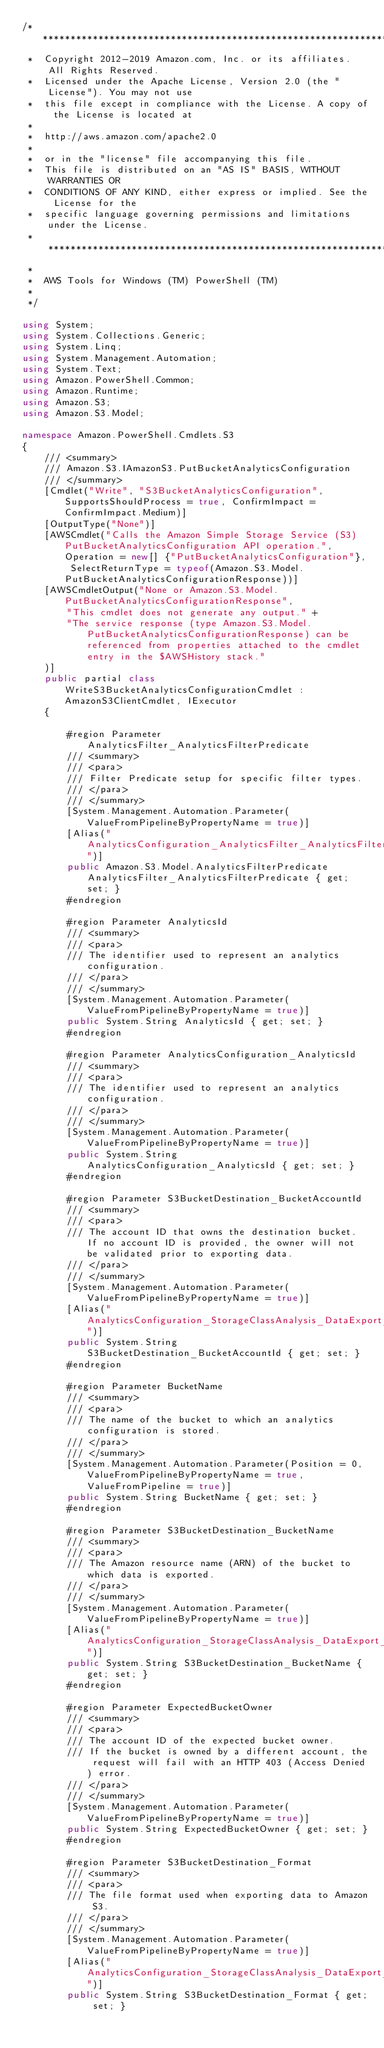<code> <loc_0><loc_0><loc_500><loc_500><_C#_>/*******************************************************************************
 *  Copyright 2012-2019 Amazon.com, Inc. or its affiliates. All Rights Reserved.
 *  Licensed under the Apache License, Version 2.0 (the "License"). You may not use
 *  this file except in compliance with the License. A copy of the License is located at
 *
 *  http://aws.amazon.com/apache2.0
 *
 *  or in the "license" file accompanying this file.
 *  This file is distributed on an "AS IS" BASIS, WITHOUT WARRANTIES OR
 *  CONDITIONS OF ANY KIND, either express or implied. See the License for the
 *  specific language governing permissions and limitations under the License.
 * *****************************************************************************
 *
 *  AWS Tools for Windows (TM) PowerShell (TM)
 *
 */

using System;
using System.Collections.Generic;
using System.Linq;
using System.Management.Automation;
using System.Text;
using Amazon.PowerShell.Common;
using Amazon.Runtime;
using Amazon.S3;
using Amazon.S3.Model;

namespace Amazon.PowerShell.Cmdlets.S3
{
    /// <summary>
    /// Amazon.S3.IAmazonS3.PutBucketAnalyticsConfiguration
    /// </summary>
    [Cmdlet("Write", "S3BucketAnalyticsConfiguration", SupportsShouldProcess = true, ConfirmImpact = ConfirmImpact.Medium)]
    [OutputType("None")]
    [AWSCmdlet("Calls the Amazon Simple Storage Service (S3) PutBucketAnalyticsConfiguration API operation.", Operation = new[] {"PutBucketAnalyticsConfiguration"}, SelectReturnType = typeof(Amazon.S3.Model.PutBucketAnalyticsConfigurationResponse))]
    [AWSCmdletOutput("None or Amazon.S3.Model.PutBucketAnalyticsConfigurationResponse",
        "This cmdlet does not generate any output." +
        "The service response (type Amazon.S3.Model.PutBucketAnalyticsConfigurationResponse) can be referenced from properties attached to the cmdlet entry in the $AWSHistory stack."
    )]
    public partial class WriteS3BucketAnalyticsConfigurationCmdlet : AmazonS3ClientCmdlet, IExecutor
    {
        
        #region Parameter AnalyticsFilter_AnalyticsFilterPredicate
        /// <summary>
        /// <para>
        /// Filter Predicate setup for specific filter types.
        /// </para>
        /// </summary>
        [System.Management.Automation.Parameter(ValueFromPipelineByPropertyName = true)]
        [Alias("AnalyticsConfiguration_AnalyticsFilter_AnalyticsFilterPredicate")]
        public Amazon.S3.Model.AnalyticsFilterPredicate AnalyticsFilter_AnalyticsFilterPredicate { get; set; }
        #endregion
        
        #region Parameter AnalyticsId
        /// <summary>
        /// <para>
        /// The identifier used to represent an analytics configuration.
        /// </para>
        /// </summary>
        [System.Management.Automation.Parameter(ValueFromPipelineByPropertyName = true)]
        public System.String AnalyticsId { get; set; }
        #endregion
        
        #region Parameter AnalyticsConfiguration_AnalyticsId
        /// <summary>
        /// <para>
        /// The identifier used to represent an analytics configuration.
        /// </para>
        /// </summary>
        [System.Management.Automation.Parameter(ValueFromPipelineByPropertyName = true)]
        public System.String AnalyticsConfiguration_AnalyticsId { get; set; }
        #endregion
        
        #region Parameter S3BucketDestination_BucketAccountId
        /// <summary>
        /// <para>
        /// The account ID that owns the destination bucket. If no account ID is provided, the owner will not be validated prior to exporting data.
        /// </para>
        /// </summary>
        [System.Management.Automation.Parameter(ValueFromPipelineByPropertyName = true)]
        [Alias("AnalyticsConfiguration_StorageClassAnalysis_DataExport_Destination_S3BucketDestination_BucketAccountId")]
        public System.String S3BucketDestination_BucketAccountId { get; set; }
        #endregion
        
        #region Parameter BucketName
        /// <summary>
        /// <para>
        /// The name of the bucket to which an analytics configuration is stored.
        /// </para>
        /// </summary>
        [System.Management.Automation.Parameter(Position = 0, ValueFromPipelineByPropertyName = true, ValueFromPipeline = true)]
        public System.String BucketName { get; set; }
        #endregion
        
        #region Parameter S3BucketDestination_BucketName
        /// <summary>
        /// <para>
        /// The Amazon resource name (ARN) of the bucket to which data is exported.
        /// </para>
        /// </summary>
        [System.Management.Automation.Parameter(ValueFromPipelineByPropertyName = true)]
        [Alias("AnalyticsConfiguration_StorageClassAnalysis_DataExport_Destination_S3BucketDestination_BucketName")]
        public System.String S3BucketDestination_BucketName { get; set; }
        #endregion
        
        #region Parameter ExpectedBucketOwner
        /// <summary>
        /// <para>
        /// The account ID of the expected bucket owner. 
        /// If the bucket is owned by a different account, the request will fail with an HTTP 403 (Access Denied) error.
        /// </para>
        /// </summary>
        [System.Management.Automation.Parameter(ValueFromPipelineByPropertyName = true)]
        public System.String ExpectedBucketOwner { get; set; }
        #endregion
        
        #region Parameter S3BucketDestination_Format
        /// <summary>
        /// <para>
        /// The file format used when exporting data to Amazon S3.
        /// </para>
        /// </summary>
        [System.Management.Automation.Parameter(ValueFromPipelineByPropertyName = true)]
        [Alias("AnalyticsConfiguration_StorageClassAnalysis_DataExport_Destination_S3BucketDestination_Format")]
        public System.String S3BucketDestination_Format { get; set; }</code> 